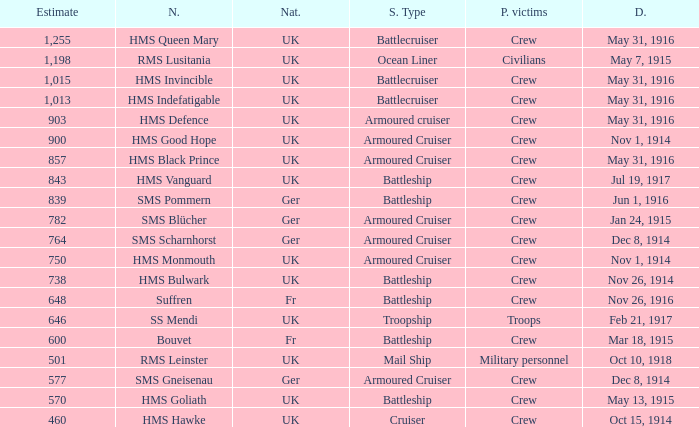What is the name of the battleship with the battle listed on may 13, 1915? HMS Goliath. Help me parse the entirety of this table. {'header': ['Estimate', 'N.', 'Nat.', 'S. Type', 'P. victims', 'D.'], 'rows': [['1,255', 'HMS Queen Mary', 'UK', 'Battlecruiser', 'Crew', 'May 31, 1916'], ['1,198', 'RMS Lusitania', 'UK', 'Ocean Liner', 'Civilians', 'May 7, 1915'], ['1,015', 'HMS Invincible', 'UK', 'Battlecruiser', 'Crew', 'May 31, 1916'], ['1,013', 'HMS Indefatigable', 'UK', 'Battlecruiser', 'Crew', 'May 31, 1916'], ['903', 'HMS Defence', 'UK', 'Armoured cruiser', 'Crew', 'May 31, 1916'], ['900', 'HMS Good Hope', 'UK', 'Armoured Cruiser', 'Crew', 'Nov 1, 1914'], ['857', 'HMS Black Prince', 'UK', 'Armoured Cruiser', 'Crew', 'May 31, 1916'], ['843', 'HMS Vanguard', 'UK', 'Battleship', 'Crew', 'Jul 19, 1917'], ['839', 'SMS Pommern', 'Ger', 'Battleship', 'Crew', 'Jun 1, 1916'], ['782', 'SMS Blücher', 'Ger', 'Armoured Cruiser', 'Crew', 'Jan 24, 1915'], ['764', 'SMS Scharnhorst', 'Ger', 'Armoured Cruiser', 'Crew', 'Dec 8, 1914'], ['750', 'HMS Monmouth', 'UK', 'Armoured Cruiser', 'Crew', 'Nov 1, 1914'], ['738', 'HMS Bulwark', 'UK', 'Battleship', 'Crew', 'Nov 26, 1914'], ['648', 'Suffren', 'Fr', 'Battleship', 'Crew', 'Nov 26, 1916'], ['646', 'SS Mendi', 'UK', 'Troopship', 'Troops', 'Feb 21, 1917'], ['600', 'Bouvet', 'Fr', 'Battleship', 'Crew', 'Mar 18, 1915'], ['501', 'RMS Leinster', 'UK', 'Mail Ship', 'Military personnel', 'Oct 10, 1918'], ['577', 'SMS Gneisenau', 'Ger', 'Armoured Cruiser', 'Crew', 'Dec 8, 1914'], ['570', 'HMS Goliath', 'UK', 'Battleship', 'Crew', 'May 13, 1915'], ['460', 'HMS Hawke', 'UK', 'Cruiser', 'Crew', 'Oct 15, 1914']]} 